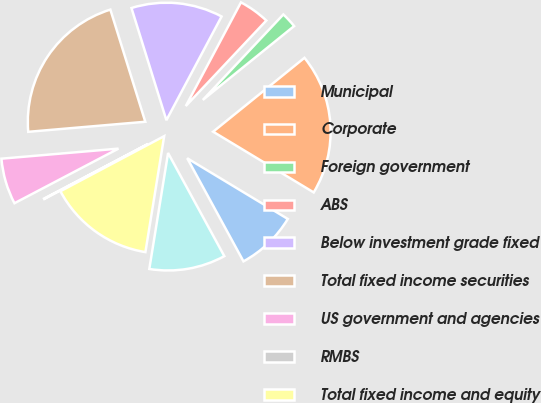<chart> <loc_0><loc_0><loc_500><loc_500><pie_chart><fcel>Municipal<fcel>Corporate<fcel>Foreign government<fcel>ABS<fcel>Below investment grade fixed<fcel>Total fixed income securities<fcel>US government and agencies<fcel>RMBS<fcel>Total fixed income and equity<fcel>Investment grade fixed income<nl><fcel>8.41%<fcel>19.47%<fcel>2.15%<fcel>4.24%<fcel>12.59%<fcel>21.56%<fcel>6.33%<fcel>0.07%<fcel>14.68%<fcel>10.5%<nl></chart> 